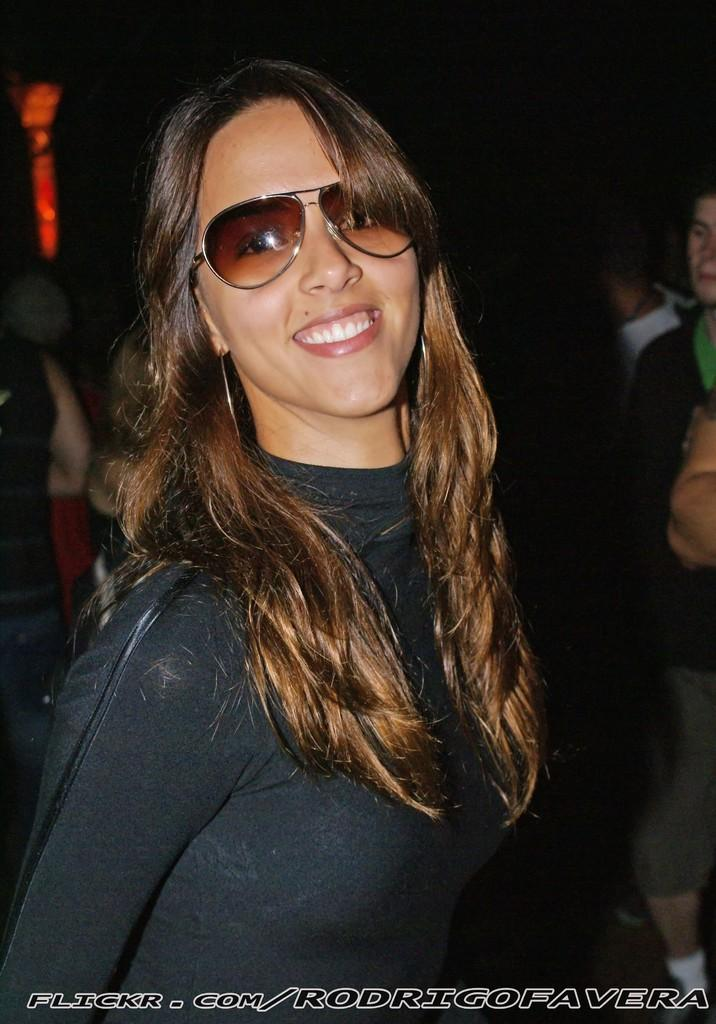Who is the main subject in the foreground of the image? There is a woman in the foreground of the image. What else can be seen in the foreground of the image? There is text in the foreground of the image. What is visible in the background of the image? There are people in the background of the image. What type of art can be seen floating in the air in the image? There is no art floating in the air in the image. How many balloons are being held by the woman in the image? The image does not show the woman holding any balloons. 